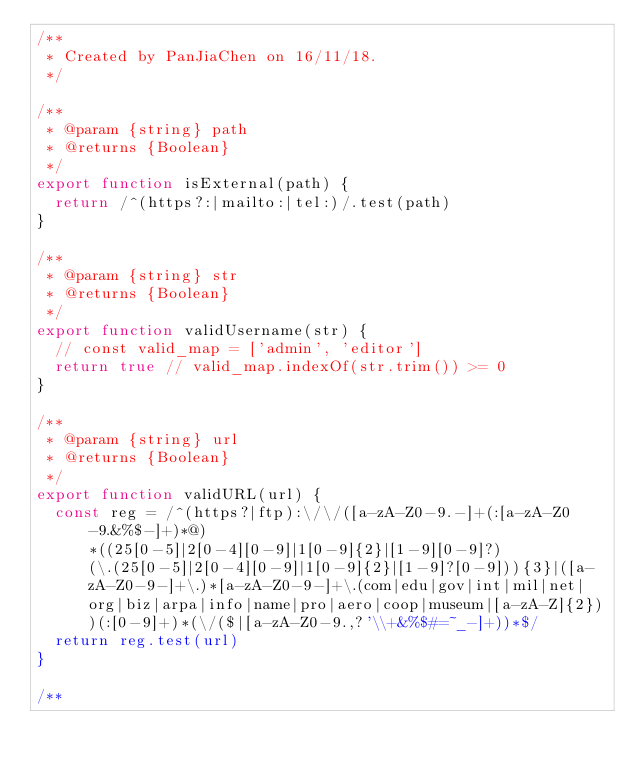Convert code to text. <code><loc_0><loc_0><loc_500><loc_500><_JavaScript_>/**
 * Created by PanJiaChen on 16/11/18.
 */

/**
 * @param {string} path
 * @returns {Boolean}
 */
export function isExternal(path) {
  return /^(https?:|mailto:|tel:)/.test(path)
}

/**
 * @param {string} str
 * @returns {Boolean}
 */
export function validUsername(str) {
  // const valid_map = ['admin', 'editor']
  return true // valid_map.indexOf(str.trim()) >= 0
}

/**
 * @param {string} url
 * @returns {Boolean}
 */
export function validURL(url) {
  const reg = /^(https?|ftp):\/\/([a-zA-Z0-9.-]+(:[a-zA-Z0-9.&%$-]+)*@)*((25[0-5]|2[0-4][0-9]|1[0-9]{2}|[1-9][0-9]?)(\.(25[0-5]|2[0-4][0-9]|1[0-9]{2}|[1-9]?[0-9])){3}|([a-zA-Z0-9-]+\.)*[a-zA-Z0-9-]+\.(com|edu|gov|int|mil|net|org|biz|arpa|info|name|pro|aero|coop|museum|[a-zA-Z]{2}))(:[0-9]+)*(\/($|[a-zA-Z0-9.,?'\\+&%$#=~_-]+))*$/
  return reg.test(url)
}

/**</code> 